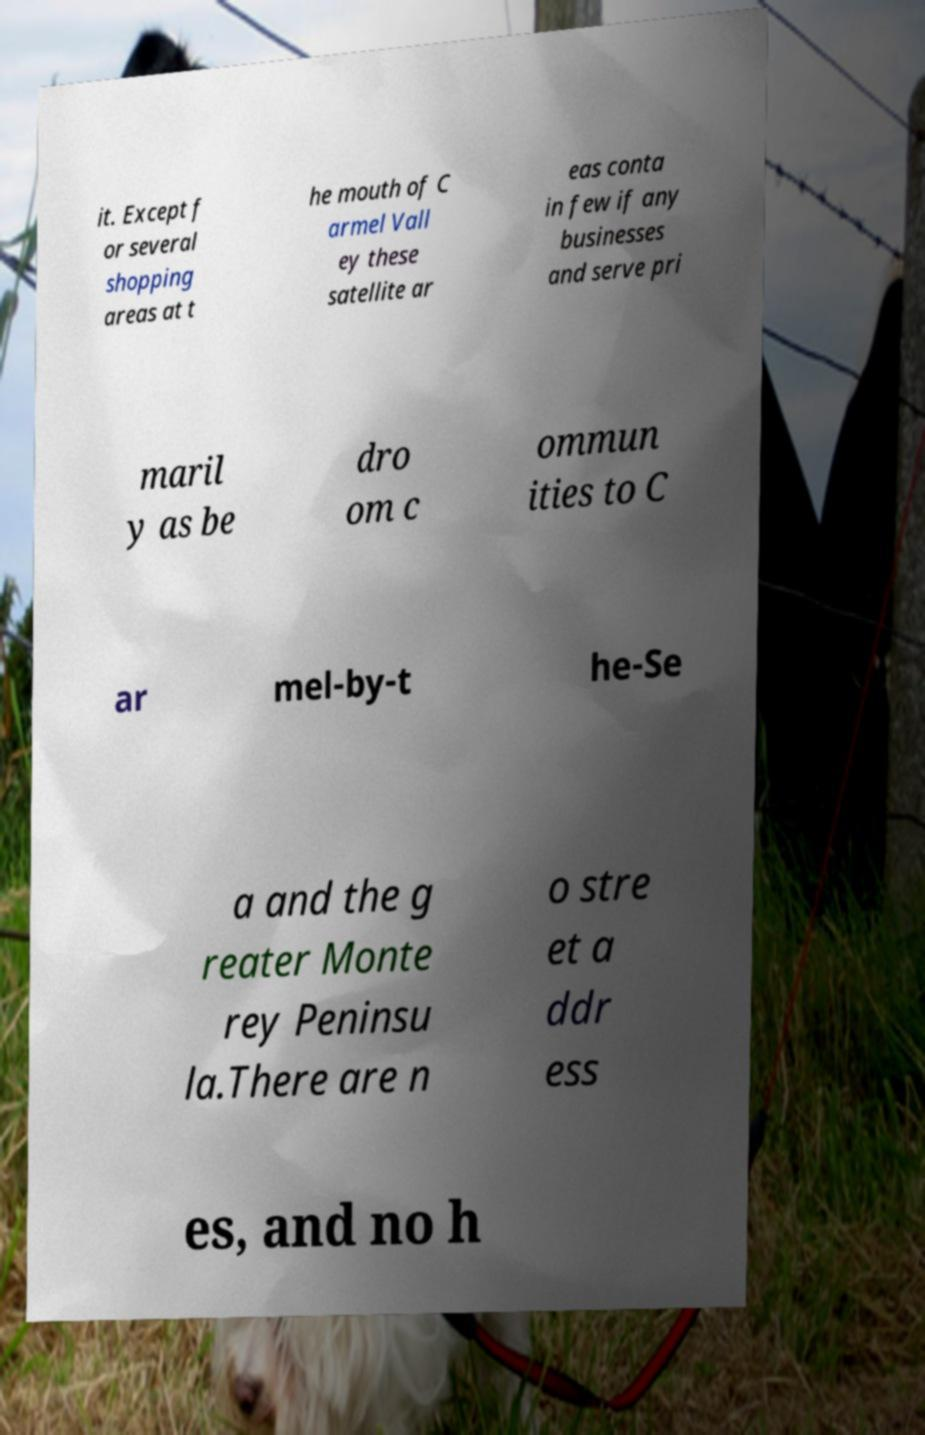Can you accurately transcribe the text from the provided image for me? it. Except f or several shopping areas at t he mouth of C armel Vall ey these satellite ar eas conta in few if any businesses and serve pri maril y as be dro om c ommun ities to C ar mel-by-t he-Se a and the g reater Monte rey Peninsu la.There are n o stre et a ddr ess es, and no h 